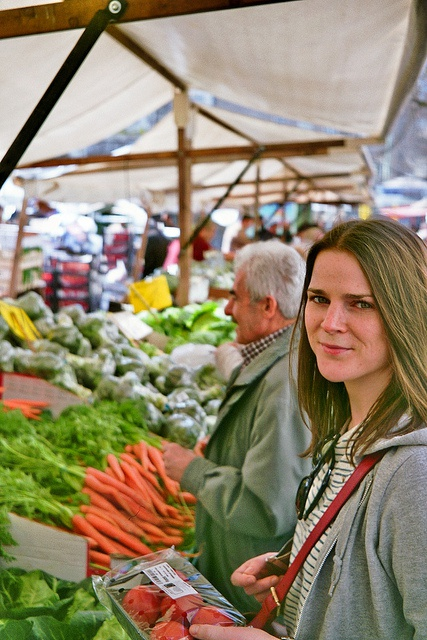Describe the objects in this image and their specific colors. I can see people in lightgray, gray, olive, darkgray, and black tones, people in lightgray, gray, darkgreen, and darkgray tones, broccoli in lightgray, darkgray, and gray tones, carrot in lightgray, red, brown, olive, and maroon tones, and broccoli in lightgray, olive, darkgray, and darkgreen tones in this image. 